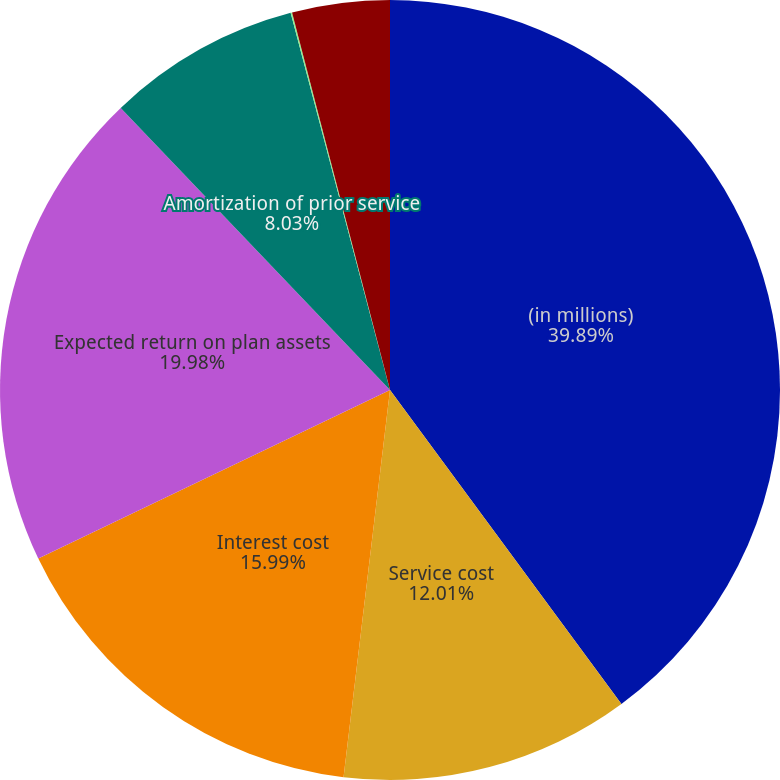<chart> <loc_0><loc_0><loc_500><loc_500><pie_chart><fcel>(in millions)<fcel>Service cost<fcel>Interest cost<fcel>Expected return on plan assets<fcel>Amortization of prior service<fcel>Amortization of net actuarial<fcel>Net periodic benefit cost<nl><fcel>39.89%<fcel>12.01%<fcel>15.99%<fcel>19.98%<fcel>8.03%<fcel>0.06%<fcel>4.04%<nl></chart> 